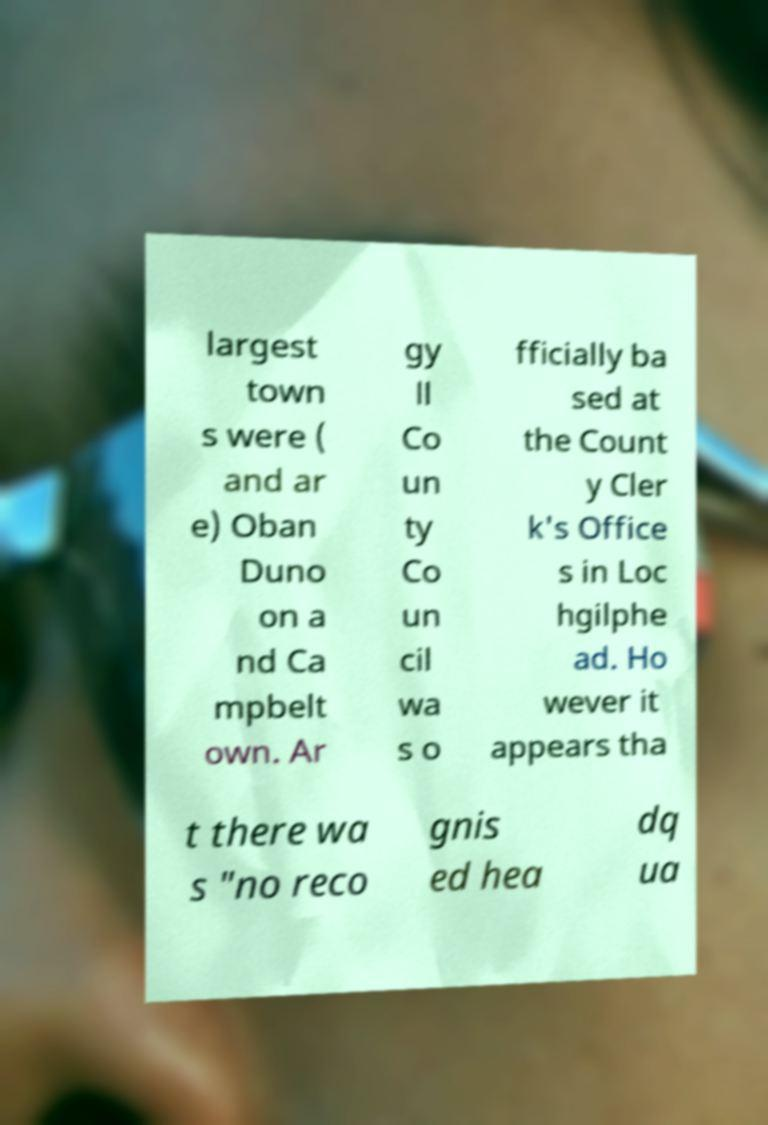Can you accurately transcribe the text from the provided image for me? largest town s were ( and ar e) Oban Duno on a nd Ca mpbelt own. Ar gy ll Co un ty Co un cil wa s o fficially ba sed at the Count y Cler k's Office s in Loc hgilphe ad. Ho wever it appears tha t there wa s "no reco gnis ed hea dq ua 